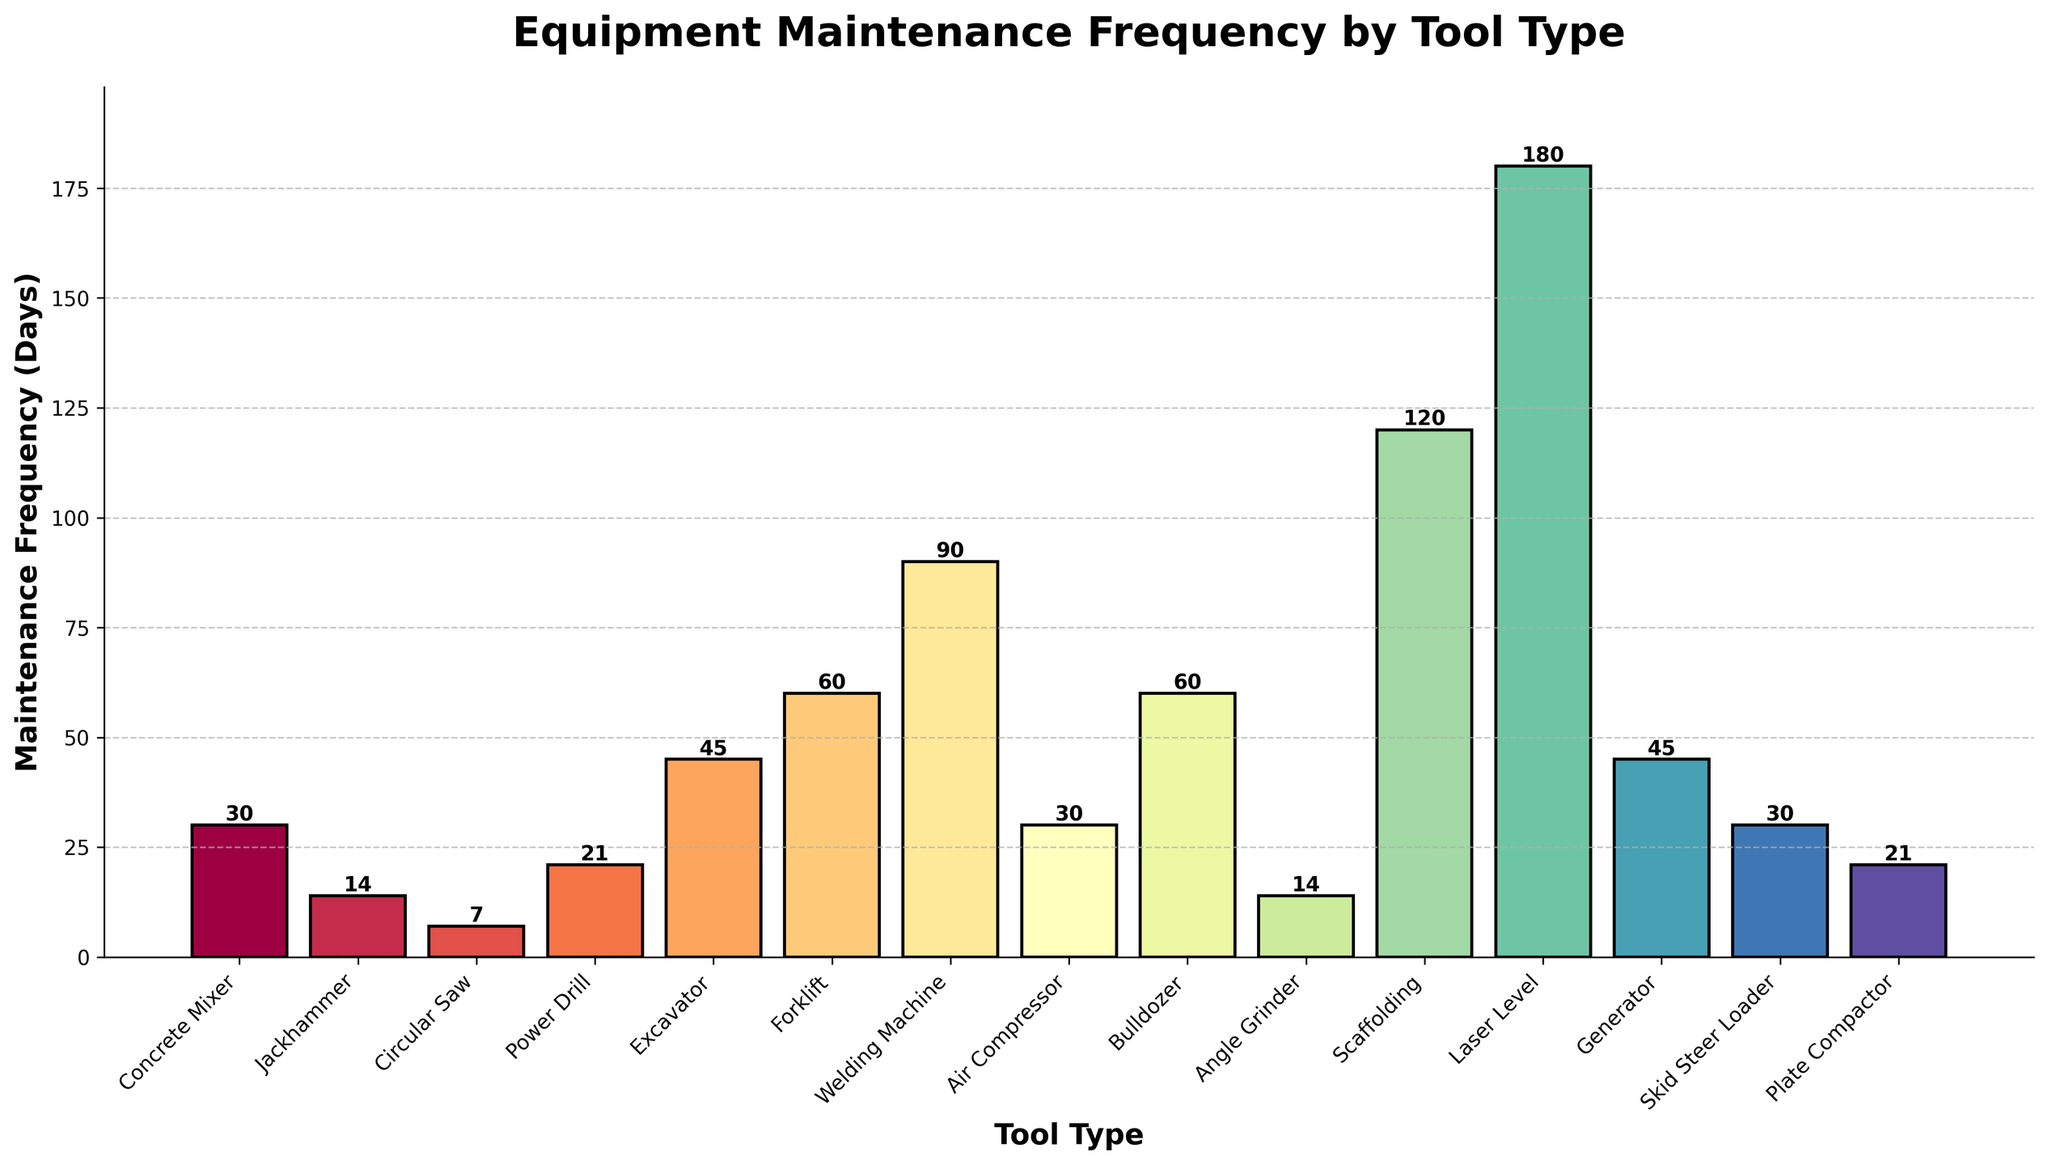Which tool has the highest maintenance frequency? The bar chart shows each tool with its maintenance frequency in days. The tool with the highest bar corresponds to the highest maintenance frequency.
Answer: Laser Level How often is the Concrete Mixer maintained compared to the Power Drill? According to the bar chart, the maintenance frequency for the Concrete Mixer is 30 days, while for the Power Drill it is 21 days. Therefore, the Concrete Mixer is maintained every 30 days, which is less frequently than the Power Drill.
Answer: Less frequently What's the combined maintenance frequency of the Jackhammer and Angle Grinder? The Jackhammer has a maintenance frequency of 14 days, and the Angle Grinder also has a maintenance frequency of 14 days. Adding these frequencies together results in 14 + 14 = 28 days.
Answer: 28 days Which tool requires more frequent maintenance, the Generator or the Skid Steer Loader? From the bar chart, the Generator has a maintenance frequency of 45 days, whereas the Skid Steer Loader has a frequency of 30 days. Therefore, the Skid Steer Loader requires more frequent maintenance.
Answer: Skid Steer Loader Are there any tools with the same maintenance frequency? The bar chart shows that both the Concrete Mixer and the Air Compressor have a maintenance frequency of 30 days, and both the Forklift and the Bulldozer have a maintenance frequency of 60 days.
Answer: Yes What is the median maintenance frequency for the tools? To find the median maintenance frequency, list all the frequencies in ascending order: 7, 14, 14, 21, 21, 30, 30, 30, 45, 45, 60, 60, 90, 120, 180. The median is the middle value, which is the 8th number in this sequence. Hence, the median maintenance frequency is 30 days.
Answer: 30 days What color is used for the bar representing the Welding Machine maintenance frequency? The visual attribute of color for each bar representing different tools may vary. Checking the bar chart, observe the bar labeled Welding Machine to determine its color.
Answer: (Answer will vary depending on the chart, typically a specific color can be mentioned, e.g., Blue) Which tool has the lowest maintenance frequency? The bar chart indicates that the Circular Saw has the lowest maintenance frequency, with a frequency of 7 days.
Answer: Circular Saw How does the maintenance frequency for the Excavator compare between the Generator and the Forklift? The bar chart shows that the Excavator has a maintenance frequency of 45 days, the Generator also 45 days, and the Forklift has a frequency of 60 days, so the Excavator has the same frequency as the Generator and lower frequency than the Forklift.
Answer: Same as Generator, less than Forklift 